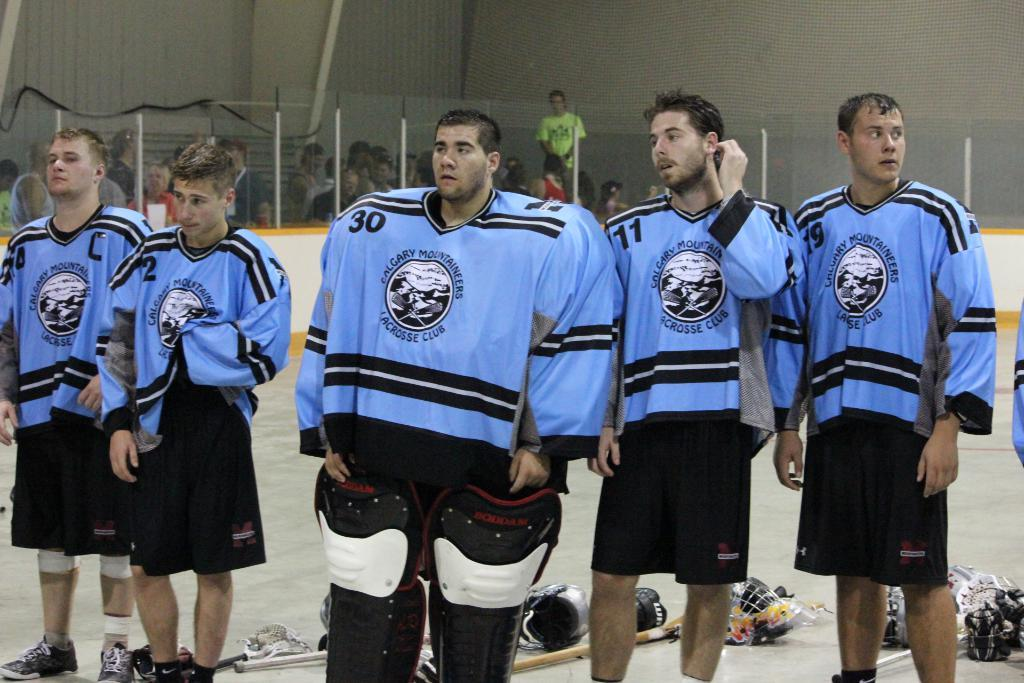<image>
Offer a succinct explanation of the picture presented. Members of a Lacrosse club from Calgary stand together wearing their jerseys. 